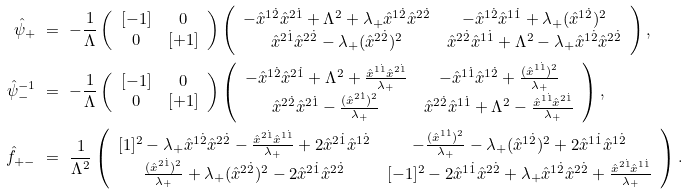Convert formula to latex. <formula><loc_0><loc_0><loc_500><loc_500>\hat { \psi } _ { + } & \ = \ - \frac { 1 } { \Lambda } \left ( \begin{array} { c c } [ - 1 ] & 0 \\ 0 & [ + 1 ] \end{array} \right ) \left ( \begin{array} { c c } - \hat { x } ^ { 1 \dot { 2 } } \hat { x } ^ { 2 \dot { 1 } } + \Lambda ^ { 2 } + \lambda _ { + } \hat { x } ^ { 1 \dot { 2 } } \hat { x } ^ { 2 \dot { 2 } } & - \hat { x } ^ { 1 \dot { 2 } } \hat { x } ^ { 1 \dot { 1 } } + \lambda _ { + } ( \hat { x } ^ { 1 \dot { 2 } } ) ^ { 2 } \\ \hat { x } ^ { 2 \dot { 1 } } \hat { x } ^ { 2 \dot { 2 } } - \lambda _ { + } ( \hat { x } ^ { 2 \dot { 2 } } ) ^ { 2 } & \hat { x } ^ { 2 \dot { 2 } } \hat { x } ^ { 1 \dot { 1 } } + \Lambda ^ { 2 } - \lambda _ { + } \hat { x } ^ { 1 \dot { 2 } } \hat { x } ^ { 2 \dot { 2 } } \end{array} \right ) , \\ \hat { \psi } ^ { - 1 } _ { - } & \ = \ - \frac { 1 } { \Lambda } \left ( \begin{array} { c c } [ - 1 ] & 0 \\ 0 & [ + 1 ] \end{array} \right ) \left ( \begin{array} { c c } - \hat { x } ^ { 1 \dot { 2 } } \hat { x } ^ { 2 \dot { 1 } } + \Lambda ^ { 2 } + \frac { \hat { x } ^ { 1 \dot { 1 } } \hat { x } ^ { 2 \dot { 1 } } } { \lambda _ { + } } & - \hat { x } ^ { 1 \dot { 1 } } \hat { x } ^ { 1 \dot { 2 } } + \frac { ( \hat { x } ^ { 1 \dot { 1 } } ) ^ { 2 } } { \lambda _ { + } } \\ \hat { x } ^ { 2 \dot { 2 } } \hat { x } ^ { 2 \dot { 1 } } - \frac { ( \hat { x } ^ { 2 \dot { 1 } } ) ^ { 2 } } { \lambda _ { + } } & \hat { x } ^ { 2 \dot { 2 } } \hat { x } ^ { 1 \dot { 1 } } + \Lambda ^ { 2 } - \frac { \hat { x } ^ { 1 \dot { 1 } } \hat { x } ^ { 2 \dot { 1 } } } { \lambda _ { + } } \end{array} \right ) , \\ \hat { f } _ { + - } & \ = \ \frac { 1 } { \Lambda ^ { 2 } } \left ( \begin{array} { c c } [ 1 ] ^ { 2 } - \lambda _ { + } \hat { x } ^ { 1 \dot { 2 } } \hat { x } ^ { 2 \dot { 2 } } - \frac { \hat { x } ^ { 2 \dot { 1 } } \hat { x } ^ { 1 \dot { 1 } } } { \lambda _ { + } } + 2 \hat { x } ^ { 2 \dot { 1 } } \hat { x } ^ { 1 \dot { 2 } } & - \frac { ( \hat { x } ^ { 1 \dot { 1 } } ) ^ { 2 } } { \lambda _ { + } } - \lambda _ { + } ( \hat { x } ^ { 1 \dot { 2 } } ) ^ { 2 } + 2 \hat { x } ^ { 1 \dot { 1 } } \hat { x } ^ { 1 \dot { 2 } } \\ \frac { ( \hat { x } ^ { 2 \dot { 1 } } ) ^ { 2 } } { \lambda _ { + } } + \lambda _ { + } ( \hat { x } ^ { 2 \dot { 2 } } ) ^ { 2 } - 2 \hat { x } ^ { 2 \dot { 1 } } \hat { x } ^ { 2 \dot { 2 } } & [ - 1 ] ^ { 2 } - 2 \hat { x } ^ { 1 \dot { 1 } } \hat { x } ^ { 2 \dot { 2 } } + \lambda _ { + } \hat { x } ^ { 1 \dot { 2 } } \hat { x } ^ { 2 \dot { 2 } } + \frac { \hat { x } ^ { 2 \dot { 1 } } \hat { x } ^ { 1 \dot { 1 } } } { \lambda _ { + } } \end{array} \right ) .</formula> 